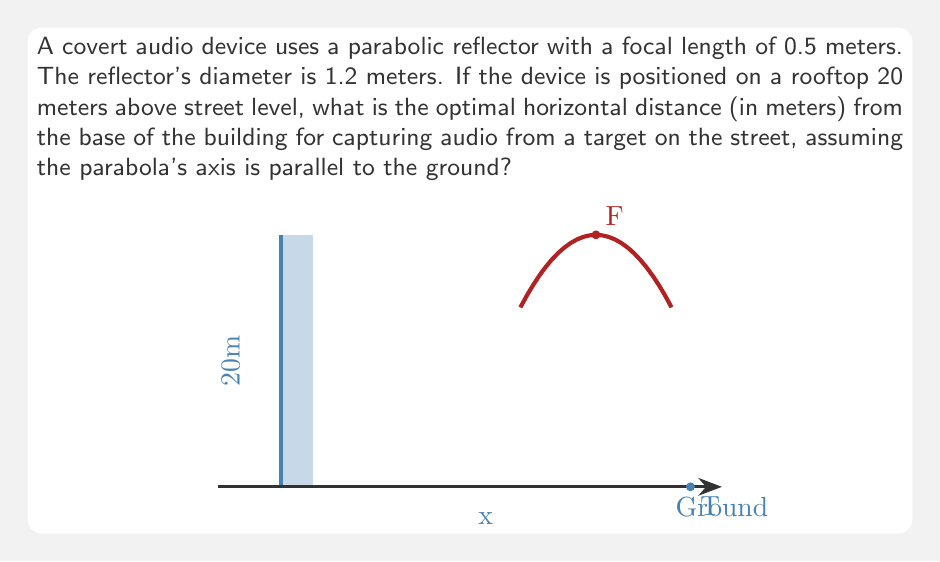Could you help me with this problem? Let's approach this step-by-step:

1) In a parabolic reflector, sound waves parallel to the axis converge at the focal point. The equation of a parabola with vertex at (0,0) and focal length $f$ is:

   $$y = \frac{1}{4f}x^2$$

2) The diameter of the reflector is 1.2m, so its radius is 0.6m. This represents the maximum x-value on the parabola. We can use this to find the y-value of the edge of the reflector:

   $$y = \frac{1}{4(0.5)}(0.6)^2 = 0.18m$$

3) The total height of the parabola is thus 0.18m. The center of the parabola is positioned 20m above the ground, so the bottom edge is at 19.91m and the top edge is at 20.09m.

4) For optimal listening, the target should be at the focal point of the parabola when the sound reaches the reflector. Given that the focal length is 0.5m, the focal point is 0.5m in front of the vertex of the parabola.

5) We can now set up a right triangle:
   - The vertical side is 19.91m (distance from ground to bottom of parabola)
   - The horizontal side is what we're looking for (let's call it x)
   - The hypotenuse is from the bottom edge of the parabola to the target

6) Using the Pythagorean theorem:

   $$x^2 + 19.91^2 = (x + 0.5)^2$$

7) Expanding:

   $$x^2 + 396.4081 = x^2 + x + 0.25$$

8) Simplifying:

   $$396.1581 = x$$

9) Therefore, the optimal horizontal distance is approximately 19.90 meters.
Answer: 19.90 meters 